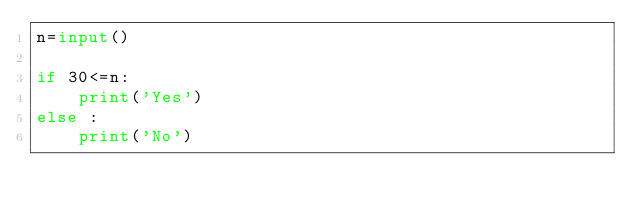Convert code to text. <code><loc_0><loc_0><loc_500><loc_500><_Python_>n=input()

if 30<=n:
    print('Yes')
else :
    print('No')
</code> 